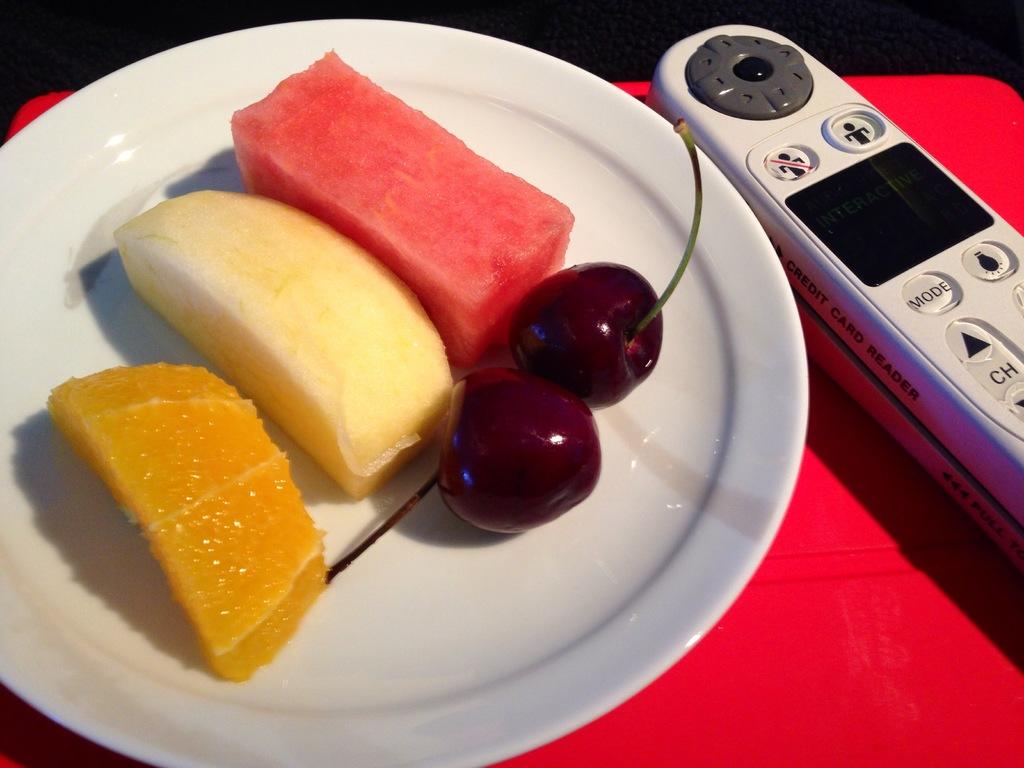Is there a "mode" button?
Provide a short and direct response. Yes. 